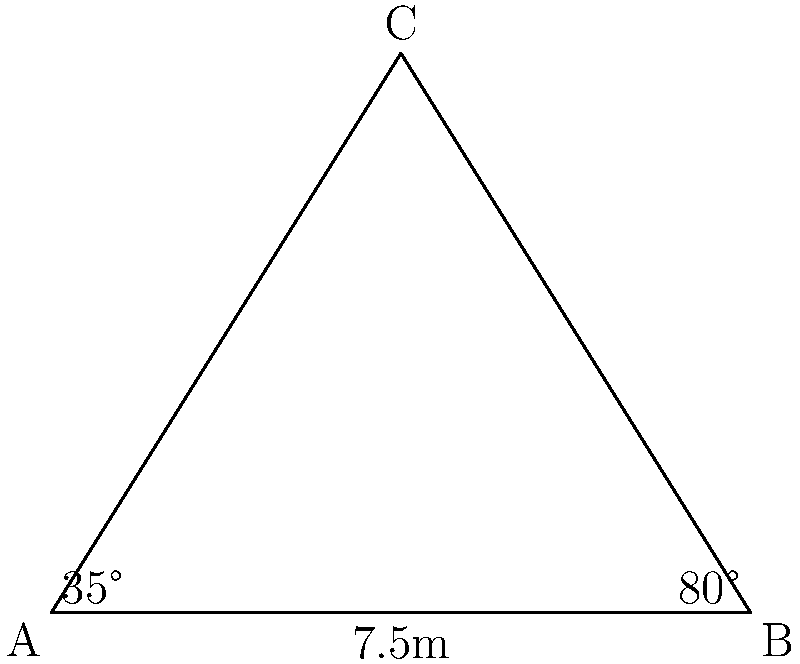Pour une scène triangulaire, vous avez mesuré la base AB à 7.5 mètres et les angles adjacents à 35° et 80°. Quelle est la longueur du côté AC en mètres, arrondie au dixième près? Pour résoudre ce problème, nous utiliserons la loi des sines. Voici les étapes:

1) La loi des sines s'énonce comme suit:
   $$\frac{a}{\sin A} = \frac{b}{\sin B} = \frac{c}{\sin C}$$
   où a, b, c sont les longueurs des côtés opposés aux angles A, B, C respectivement.

2) Nous connaissons:
   - AB = 7.5m (c'est a dans la formule)
   - ∠CAB = 35° (c'est A dans la formule)
   - ∠CBA = 80° (c'est B dans la formule)

3) Nous cherchons AC (c'est b dans la formule)

4) L'angle C peut être calculé: C = 180° - (35° + 80°) = 65°

5) Appliquons la loi des sines:
   $$\frac{7.5}{\sin 65°} = \frac{b}{\sin 35°}$$

6) Résolvons pour b:
   $$b = \frac{7.5 \cdot \sin 35°}{\sin 65°}$$

7) Calculons:
   $$b \approx 4.74$$

8) Arrondi au dixième: 4.7m
Answer: 4.7m 